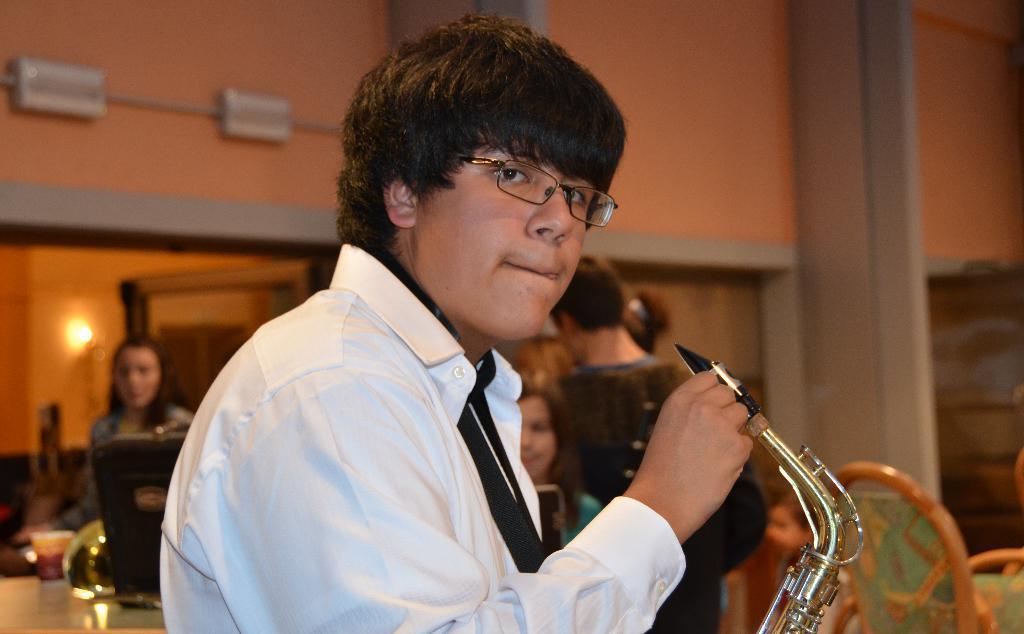Could you give a brief overview of what you see in this image? In the middle of the image there is a man with white shirt is holding a musical instrument in his hand. To the right bottom of the image there are chairs. And behind him there are few people. And to the bottom left of the image there is a table with a few items on it. And in the background there is a wall with orange color. 